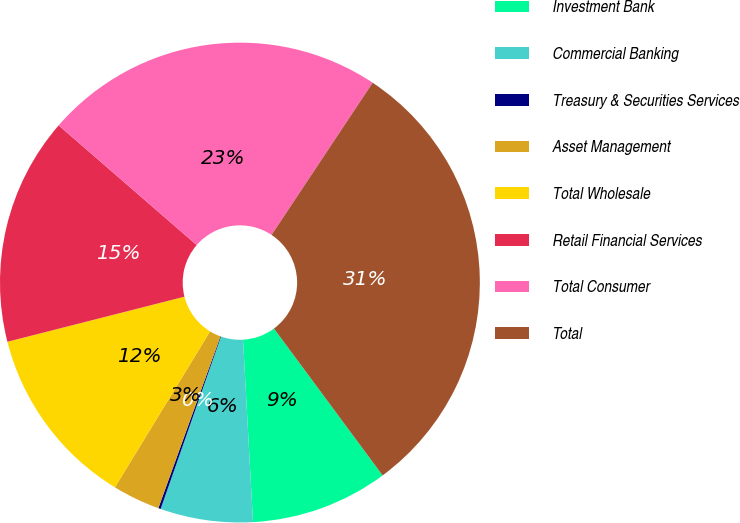<chart> <loc_0><loc_0><loc_500><loc_500><pie_chart><fcel>Investment Bank<fcel>Commercial Banking<fcel>Treasury & Securities Services<fcel>Asset Management<fcel>Total Wholesale<fcel>Retail Financial Services<fcel>Total Consumer<fcel>Total<nl><fcel>9.27%<fcel>6.23%<fcel>0.16%<fcel>3.2%<fcel>12.31%<fcel>15.34%<fcel>22.96%<fcel>30.53%<nl></chart> 